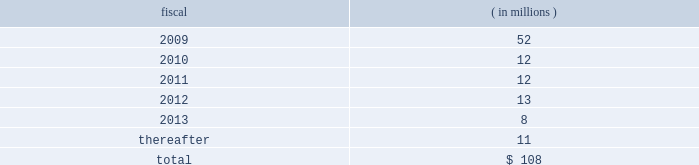Visa inc .
Notes to consolidated financial statements 2014 ( continued ) september 30 , 2008 ( in millions , except as noted ) secured notes series b-1995 lease agreement in september 1995 , a real estate partnership owned jointly by visa u.s.a .
And visa international issued notes that are secured by certain office properties and facilities in california which are used by the company through a lease financing of net-leased office space ( 201c1995 lease agreement 201d ) .
Series b of these notes , totaling $ 27 million , were issued with an interest rate of 7.83% ( 7.83 % ) and a stated maturity of september 15 , 2015 , and are payable monthly with interest-only payments for the first ten years and payments of interest and principal for the remainder of the term .
Series b debt issuance costs of $ 0.3 million and a $ 0.8 million loss on termination of a forward contract are being amortized on a straight- line basis over the life of the notes .
The settlement entered into in connection with visa check/ master money antitrust litigation had triggered an event of default under the 1995 lease agreement .
Accordingly , the related debt was classified as a current liability at september 30 , 2007 .
In may 2008 , visa inc. , visa u.s.a .
And visa international executed an amendment and waiver to the 1995 lease agreement ( 201camended 1995 lease agreement 201d ) , curing the default and including a guarantee of remaining obligations under the agreement by visa inc .
The interest terms remained unchanged .
Future principal payments future principal payments on the company 2019s outstanding debt are as follows: .
U.s .
Commercial paper program visa international maintains a u.s .
Commercial paper program to support its working capital requirements and for general corporate purposes .
This program allows the company to issue up to $ 500 million of unsecured debt securities , with maturities up to 270 days from the date of issuance and at interest rates generally extended to companies with comparable credit ratings .
At september 30 , 2008 , the company had no outstanding obligations under this program .
Revolving credit facilities on february 15 , 2008 , visa inc .
Entered into a $ 3.0 billion five-year revolving credit facility ( the 201cfebruary 2008 agreement 201d ) which replaced visa international 2019s $ 2.25 billion credit facility .
The february 2008 agreement matures on february 15 , 2013 and contains covenants and events of defaults customary for facilities of this type .
At september 30 , 2008 , the company is in compliance with all covenants with respect to the revolving credit facility. .
What portion of future principal payments are due in 2009? 
Computations: (52 / 108)
Answer: 0.48148. 